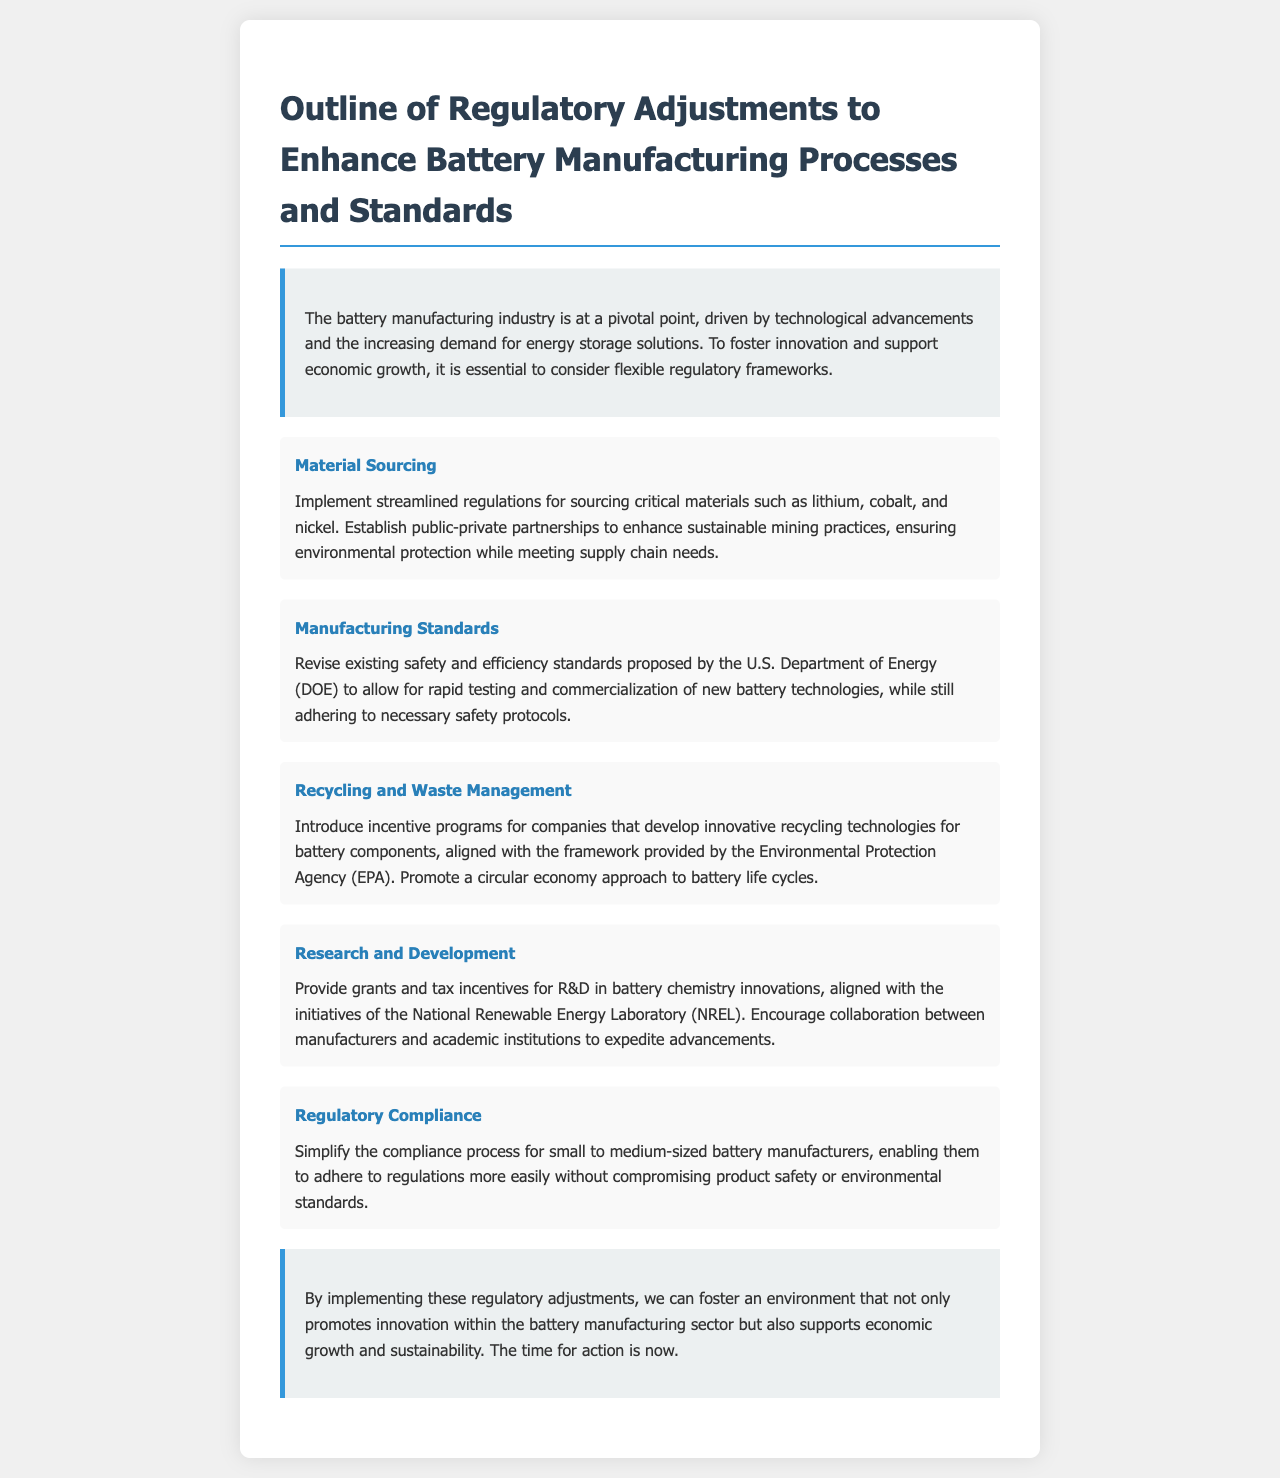What is the title of the document? The title is prominently displayed at the top of the document and is "Outline of Regulatory Adjustments to Enhance Battery Manufacturing Processes and Standards."
Answer: Outline of Regulatory Adjustments to Enhance Battery Manufacturing Processes and Standards What critical materials are mentioned for sourcing? The letter specifies lithium, cobalt, and nickel as critical materials for sourcing in battery manufacturing.
Answer: Lithium, cobalt, and nickel Which agency's proposed standards are to be revised? The existing safety and efficiency standards proposed by the U.S. Department of Energy (DOE) are mentioned for revision in the document.
Answer: U.S. Department of Energy (DOE) What approach does the document suggest for battery life cycles? The document suggests promoting a circular economy approach for battery life cycles to support recycling and waste management initiatives.
Answer: Circular economy What tax incentives are discussed in relation to R&D? The document discusses grants and tax incentives for research and development in battery chemistry innovations.
Answer: Grants and tax incentives How many adjustment areas are outlined in the document? The document outlines five distinct areas for adjustments in battery manufacturing regulations.
Answer: Five What is the main goal of the proposed regulatory adjustments? The main goal stated in the document is to foster innovation and support economic growth in the battery manufacturing sector.
Answer: Foster innovation and support economic growth Which organization is mentioned for incentive programs related to recycling? The Environmental Protection Agency (EPA) is mentioned in relation to introducing incentive programs for innovative recycling technologies.
Answer: Environmental Protection Agency (EPA) What is the suggested simplification for small manufacturers? The document suggests simplifying the compliance process for small to medium-sized battery manufacturers to help them adhere to regulations.
Answer: Simplifying the compliance process 